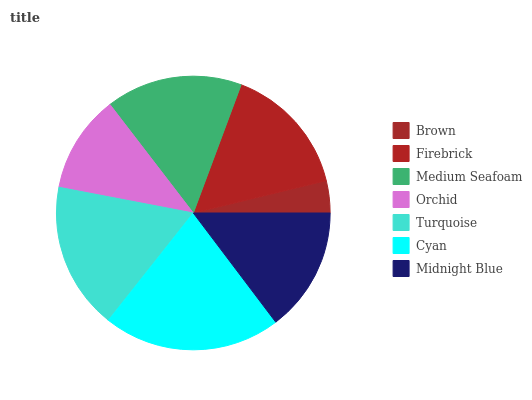Is Brown the minimum?
Answer yes or no. Yes. Is Cyan the maximum?
Answer yes or no. Yes. Is Firebrick the minimum?
Answer yes or no. No. Is Firebrick the maximum?
Answer yes or no. No. Is Firebrick greater than Brown?
Answer yes or no. Yes. Is Brown less than Firebrick?
Answer yes or no. Yes. Is Brown greater than Firebrick?
Answer yes or no. No. Is Firebrick less than Brown?
Answer yes or no. No. Is Firebrick the high median?
Answer yes or no. Yes. Is Firebrick the low median?
Answer yes or no. Yes. Is Orchid the high median?
Answer yes or no. No. Is Midnight Blue the low median?
Answer yes or no. No. 